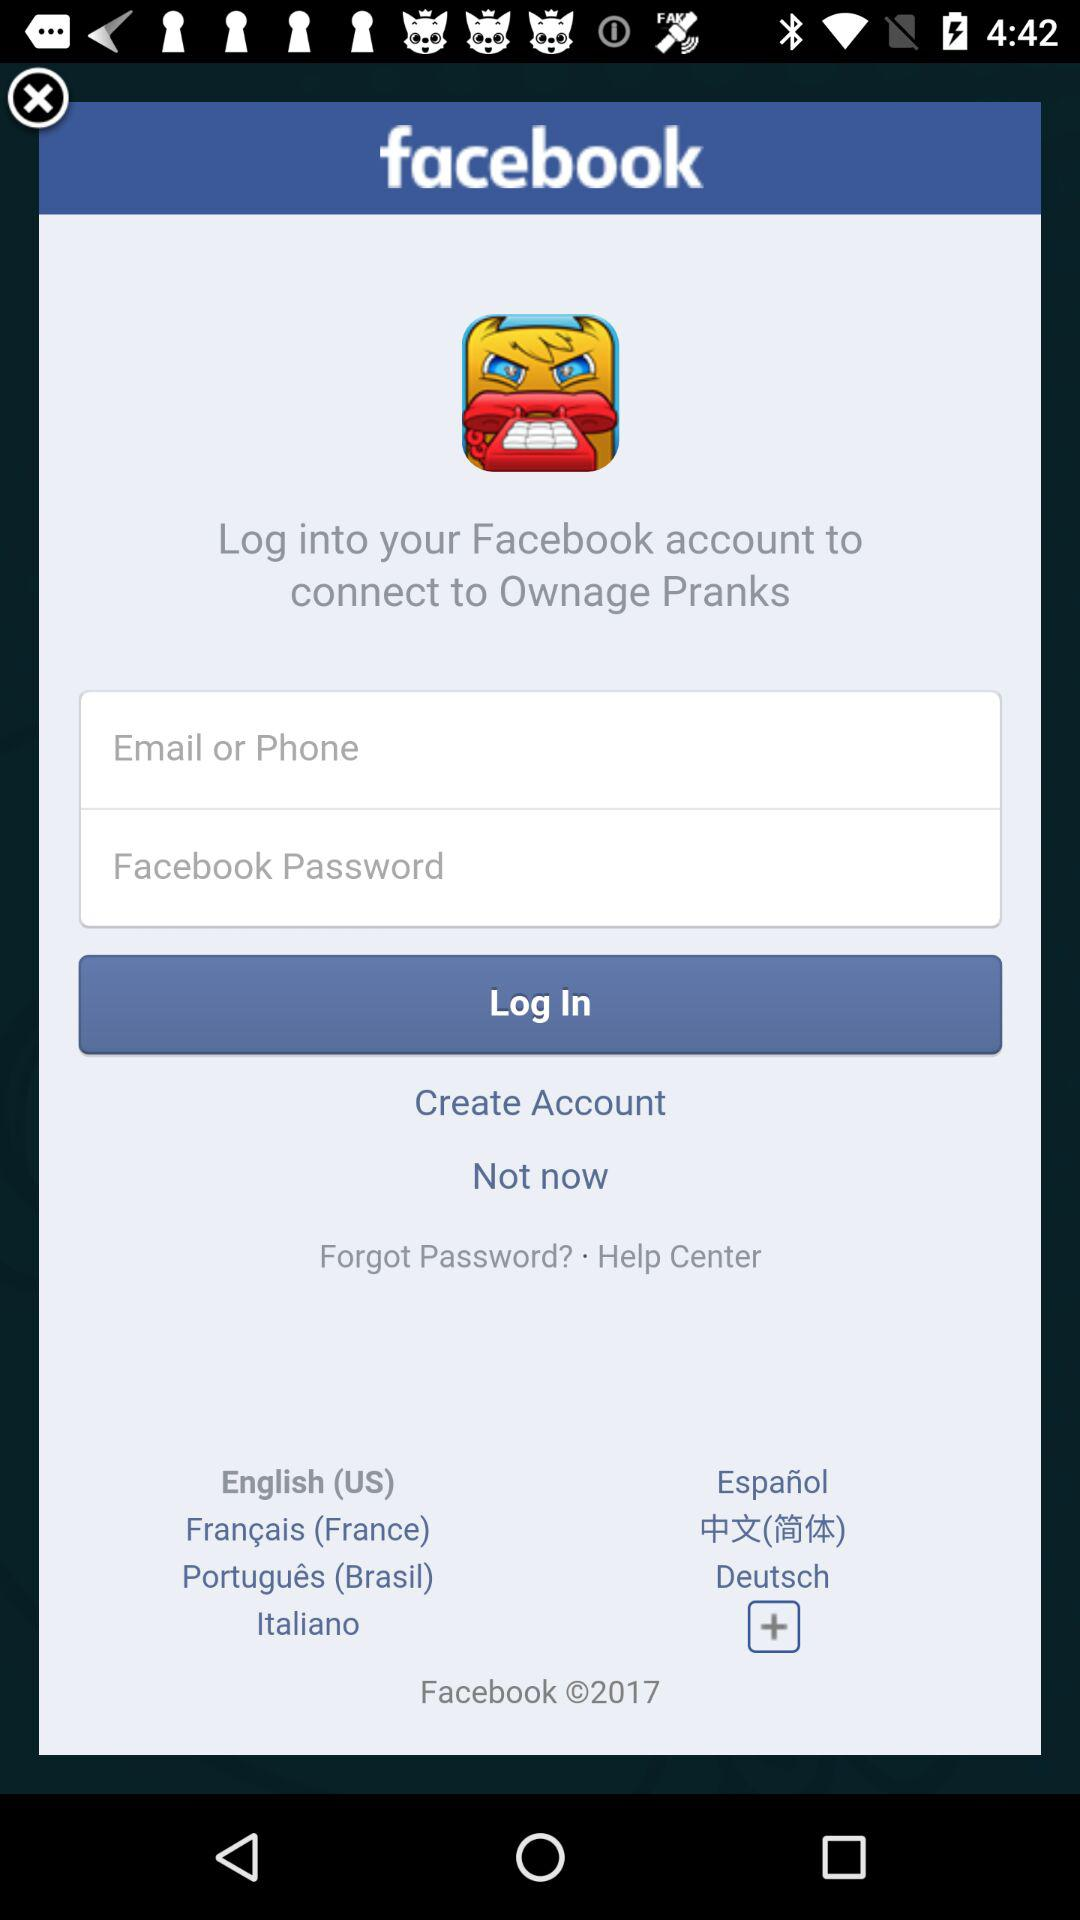What is the application name? The application name is "facebook". 